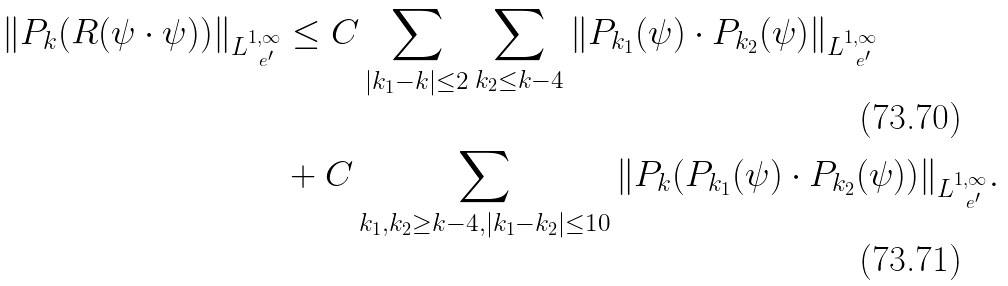Convert formula to latex. <formula><loc_0><loc_0><loc_500><loc_500>\| P _ { k } ( R ( \psi \cdot \psi ) ) \| _ { L ^ { 1 , \infty } _ { \ e ^ { \prime } } } & \leq C \sum _ { | k _ { 1 } - k | \leq 2 } \sum _ { k _ { 2 } \leq k - 4 } \| P _ { k _ { 1 } } ( \psi ) \cdot P _ { k _ { 2 } } ( \psi ) \| _ { L ^ { 1 , \infty } _ { \ e ^ { \prime } } } \\ & + C \sum _ { k _ { 1 } , k _ { 2 } \geq k - 4 , | k _ { 1 } - k _ { 2 } | \leq 1 0 } \| P _ { k } ( P _ { k _ { 1 } } ( \psi ) \cdot P _ { k _ { 2 } } ( \psi ) ) \| _ { L ^ { 1 , \infty } _ { \ e ^ { \prime } } } .</formula> 